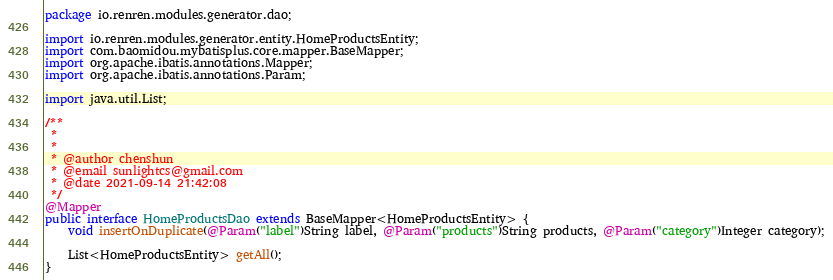<code> <loc_0><loc_0><loc_500><loc_500><_Java_>package io.renren.modules.generator.dao;

import io.renren.modules.generator.entity.HomeProductsEntity;
import com.baomidou.mybatisplus.core.mapper.BaseMapper;
import org.apache.ibatis.annotations.Mapper;
import org.apache.ibatis.annotations.Param;

import java.util.List;

/**
 * 
 * 
 * @author chenshun
 * @email sunlightcs@gmail.com
 * @date 2021-09-14 21:42:08
 */
@Mapper
public interface HomeProductsDao extends BaseMapper<HomeProductsEntity> {
	void insertOnDuplicate(@Param("label")String label, @Param("products")String products, @Param("category")Integer category);

	List<HomeProductsEntity> getAll();
}
</code> 